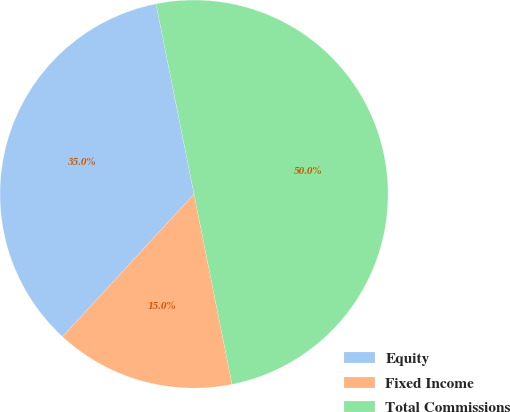Convert chart. <chart><loc_0><loc_0><loc_500><loc_500><pie_chart><fcel>Equity<fcel>Fixed Income<fcel>Total Commissions<nl><fcel>35.0%<fcel>15.0%<fcel>50.0%<nl></chart> 